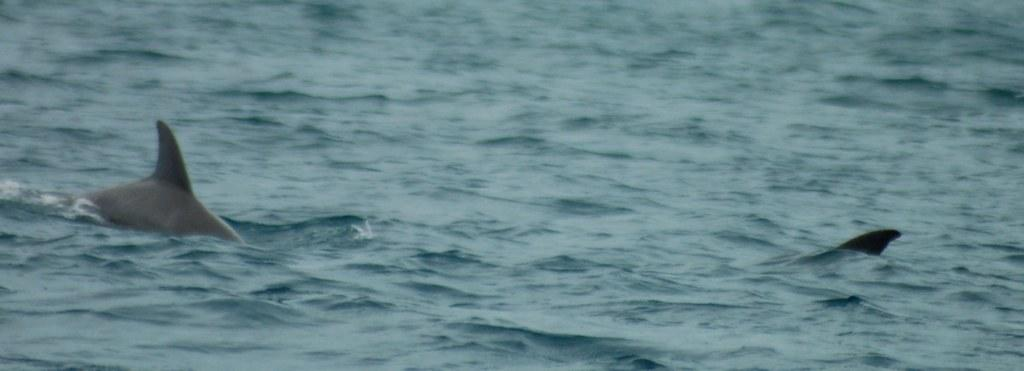What is visible in the image? There is water visible in the image. Are there any living creatures in the water? Yes, there are two aquatic animals in the water. What invention can be seen in the image? There is no invention present in the image; it features water and two aquatic animals. What is the wealth status of the aquatic animals in the image? There is no information about the wealth status of the aquatic animals in the image, as they are wild animals in their natural habitat. 